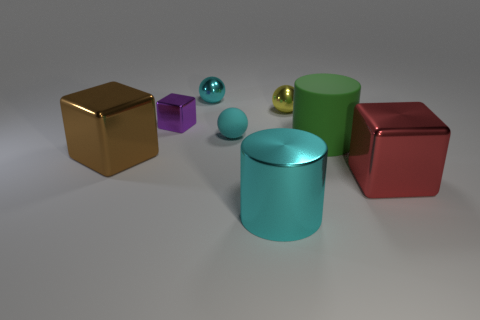What number of small spheres are behind the cyan ball that is behind the purple metallic cube?
Provide a short and direct response. 0. Are the red block and the yellow ball made of the same material?
Provide a succinct answer. Yes. What number of cyan shiny objects are behind the large cylinder that is behind the big shiny block that is to the right of the large cyan shiny cylinder?
Ensure brevity in your answer.  1. The ball in front of the tiny yellow object is what color?
Offer a very short reply. Cyan. What is the shape of the large shiny thing behind the large shiny block that is on the right side of the large green matte object?
Ensure brevity in your answer.  Cube. Do the small cube and the shiny cylinder have the same color?
Your answer should be very brief. No. What number of cylinders are either yellow shiny things or small things?
Provide a short and direct response. 0. There is a thing that is both in front of the large green object and left of the big cyan shiny thing; what material is it?
Your response must be concise. Metal. There is a small purple metallic object; what number of large matte cylinders are left of it?
Offer a very short reply. 0. Are the cylinder in front of the large brown block and the cyan ball that is in front of the small purple metallic block made of the same material?
Offer a terse response. No. 